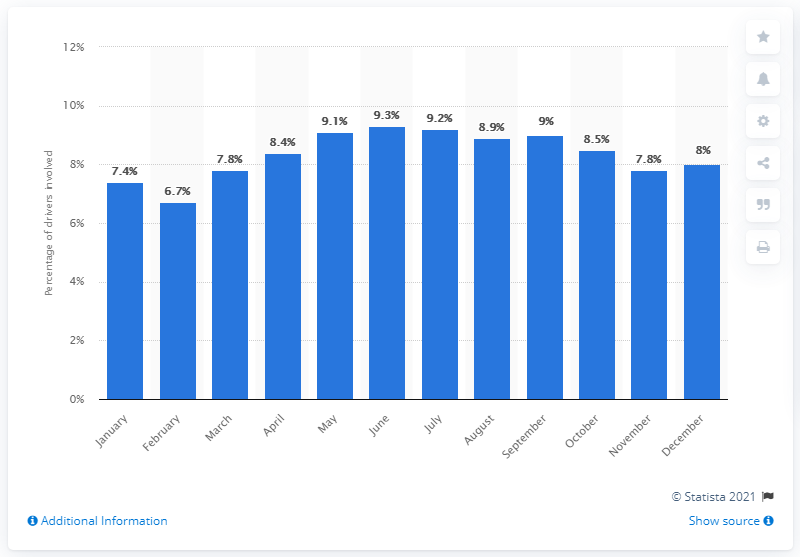Point out several critical features in this image. In February, the percentage of fatal car crashes was the lowest at 6.7%. The percentage of alcohol-impaired drivers in fatal car crashes peaked in June. 